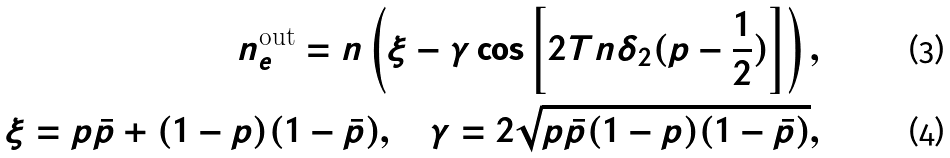<formula> <loc_0><loc_0><loc_500><loc_500>n _ { e } ^ { \text {out} } = n \left ( \xi - \gamma \cos \left [ 2 T n \delta _ { 2 } ( p - \frac { 1 } { 2 } ) \right ] \right ) , \\ \xi = p \bar { p } + ( 1 - p ) ( 1 - \bar { p } ) , \quad \gamma = 2 \sqrt { p \bar { p } ( 1 - p ) ( 1 - \bar { p } ) } ,</formula> 